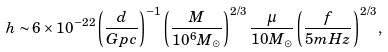Convert formula to latex. <formula><loc_0><loc_0><loc_500><loc_500>h \sim 6 \times 1 0 ^ { - 2 2 } \left ( \frac { d } { G p c } \right ) ^ { - 1 } \left ( \frac { M } { 1 0 ^ { 6 } M _ { \odot } } \right ) ^ { 2 / 3 } \frac { \mu } { 1 0 M _ { \odot } } \left ( \frac { f } { 5 m H z } \right ) ^ { 2 / 3 } ,</formula> 